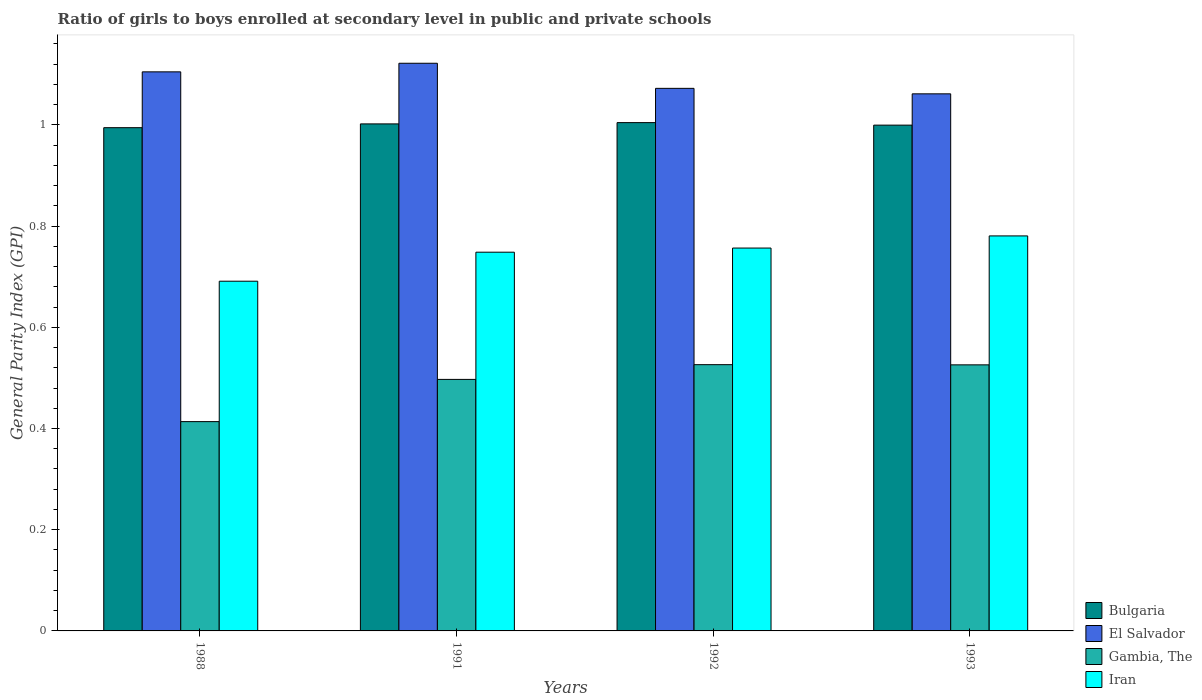Are the number of bars on each tick of the X-axis equal?
Give a very brief answer. Yes. How many bars are there on the 1st tick from the left?
Your response must be concise. 4. What is the label of the 4th group of bars from the left?
Offer a very short reply. 1993. What is the general parity index in Gambia, The in 1988?
Provide a short and direct response. 0.41. Across all years, what is the maximum general parity index in Bulgaria?
Make the answer very short. 1. Across all years, what is the minimum general parity index in El Salvador?
Give a very brief answer. 1.06. In which year was the general parity index in Bulgaria maximum?
Provide a succinct answer. 1992. What is the total general parity index in Bulgaria in the graph?
Your answer should be compact. 4. What is the difference between the general parity index in Iran in 1988 and that in 1993?
Make the answer very short. -0.09. What is the difference between the general parity index in Gambia, The in 1988 and the general parity index in Bulgaria in 1991?
Ensure brevity in your answer.  -0.59. What is the average general parity index in Iran per year?
Keep it short and to the point. 0.74. In the year 1991, what is the difference between the general parity index in El Salvador and general parity index in Gambia, The?
Make the answer very short. 0.62. What is the ratio of the general parity index in El Salvador in 1992 to that in 1993?
Ensure brevity in your answer.  1.01. Is the difference between the general parity index in El Salvador in 1988 and 1992 greater than the difference between the general parity index in Gambia, The in 1988 and 1992?
Offer a terse response. Yes. What is the difference between the highest and the second highest general parity index in Gambia, The?
Provide a succinct answer. 0. What is the difference between the highest and the lowest general parity index in Iran?
Your answer should be compact. 0.09. Is the sum of the general parity index in El Salvador in 1991 and 1992 greater than the maximum general parity index in Bulgaria across all years?
Offer a very short reply. Yes. Is it the case that in every year, the sum of the general parity index in El Salvador and general parity index in Gambia, The is greater than the sum of general parity index in Iran and general parity index in Bulgaria?
Offer a very short reply. Yes. What does the 4th bar from the left in 1993 represents?
Your answer should be compact. Iran. What does the 3rd bar from the right in 1993 represents?
Your response must be concise. El Salvador. How many bars are there?
Your answer should be compact. 16. Does the graph contain any zero values?
Provide a succinct answer. No. How many legend labels are there?
Provide a short and direct response. 4. What is the title of the graph?
Provide a short and direct response. Ratio of girls to boys enrolled at secondary level in public and private schools. What is the label or title of the Y-axis?
Your answer should be very brief. General Parity Index (GPI). What is the General Parity Index (GPI) of Bulgaria in 1988?
Give a very brief answer. 0.99. What is the General Parity Index (GPI) in El Salvador in 1988?
Keep it short and to the point. 1.1. What is the General Parity Index (GPI) of Gambia, The in 1988?
Your answer should be compact. 0.41. What is the General Parity Index (GPI) of Iran in 1988?
Offer a terse response. 0.69. What is the General Parity Index (GPI) in Bulgaria in 1991?
Offer a terse response. 1. What is the General Parity Index (GPI) of El Salvador in 1991?
Your response must be concise. 1.12. What is the General Parity Index (GPI) of Gambia, The in 1991?
Offer a terse response. 0.5. What is the General Parity Index (GPI) of Iran in 1991?
Offer a terse response. 0.75. What is the General Parity Index (GPI) of Bulgaria in 1992?
Provide a short and direct response. 1. What is the General Parity Index (GPI) in El Salvador in 1992?
Provide a succinct answer. 1.07. What is the General Parity Index (GPI) in Gambia, The in 1992?
Offer a terse response. 0.53. What is the General Parity Index (GPI) of Iran in 1992?
Your answer should be very brief. 0.76. What is the General Parity Index (GPI) of Bulgaria in 1993?
Offer a very short reply. 1. What is the General Parity Index (GPI) of El Salvador in 1993?
Provide a succinct answer. 1.06. What is the General Parity Index (GPI) in Gambia, The in 1993?
Provide a short and direct response. 0.53. What is the General Parity Index (GPI) in Iran in 1993?
Your answer should be very brief. 0.78. Across all years, what is the maximum General Parity Index (GPI) of Bulgaria?
Your response must be concise. 1. Across all years, what is the maximum General Parity Index (GPI) in El Salvador?
Your answer should be very brief. 1.12. Across all years, what is the maximum General Parity Index (GPI) in Gambia, The?
Keep it short and to the point. 0.53. Across all years, what is the maximum General Parity Index (GPI) of Iran?
Ensure brevity in your answer.  0.78. Across all years, what is the minimum General Parity Index (GPI) of Bulgaria?
Offer a terse response. 0.99. Across all years, what is the minimum General Parity Index (GPI) in El Salvador?
Provide a short and direct response. 1.06. Across all years, what is the minimum General Parity Index (GPI) of Gambia, The?
Make the answer very short. 0.41. Across all years, what is the minimum General Parity Index (GPI) of Iran?
Ensure brevity in your answer.  0.69. What is the total General Parity Index (GPI) in Bulgaria in the graph?
Give a very brief answer. 4. What is the total General Parity Index (GPI) of El Salvador in the graph?
Offer a very short reply. 4.36. What is the total General Parity Index (GPI) of Gambia, The in the graph?
Your response must be concise. 1.96. What is the total General Parity Index (GPI) of Iran in the graph?
Give a very brief answer. 2.98. What is the difference between the General Parity Index (GPI) of Bulgaria in 1988 and that in 1991?
Offer a terse response. -0.01. What is the difference between the General Parity Index (GPI) in El Salvador in 1988 and that in 1991?
Ensure brevity in your answer.  -0.02. What is the difference between the General Parity Index (GPI) of Gambia, The in 1988 and that in 1991?
Provide a succinct answer. -0.08. What is the difference between the General Parity Index (GPI) of Iran in 1988 and that in 1991?
Offer a very short reply. -0.06. What is the difference between the General Parity Index (GPI) of Bulgaria in 1988 and that in 1992?
Keep it short and to the point. -0.01. What is the difference between the General Parity Index (GPI) of El Salvador in 1988 and that in 1992?
Give a very brief answer. 0.03. What is the difference between the General Parity Index (GPI) in Gambia, The in 1988 and that in 1992?
Keep it short and to the point. -0.11. What is the difference between the General Parity Index (GPI) in Iran in 1988 and that in 1992?
Your response must be concise. -0.07. What is the difference between the General Parity Index (GPI) of Bulgaria in 1988 and that in 1993?
Make the answer very short. -0.01. What is the difference between the General Parity Index (GPI) in El Salvador in 1988 and that in 1993?
Offer a terse response. 0.04. What is the difference between the General Parity Index (GPI) of Gambia, The in 1988 and that in 1993?
Offer a terse response. -0.11. What is the difference between the General Parity Index (GPI) in Iran in 1988 and that in 1993?
Your response must be concise. -0.09. What is the difference between the General Parity Index (GPI) of Bulgaria in 1991 and that in 1992?
Your answer should be compact. -0. What is the difference between the General Parity Index (GPI) of El Salvador in 1991 and that in 1992?
Keep it short and to the point. 0.05. What is the difference between the General Parity Index (GPI) in Gambia, The in 1991 and that in 1992?
Give a very brief answer. -0.03. What is the difference between the General Parity Index (GPI) of Iran in 1991 and that in 1992?
Give a very brief answer. -0.01. What is the difference between the General Parity Index (GPI) in Bulgaria in 1991 and that in 1993?
Offer a terse response. 0. What is the difference between the General Parity Index (GPI) of El Salvador in 1991 and that in 1993?
Give a very brief answer. 0.06. What is the difference between the General Parity Index (GPI) of Gambia, The in 1991 and that in 1993?
Make the answer very short. -0.03. What is the difference between the General Parity Index (GPI) in Iran in 1991 and that in 1993?
Provide a short and direct response. -0.03. What is the difference between the General Parity Index (GPI) in Bulgaria in 1992 and that in 1993?
Give a very brief answer. 0.01. What is the difference between the General Parity Index (GPI) of El Salvador in 1992 and that in 1993?
Provide a succinct answer. 0.01. What is the difference between the General Parity Index (GPI) in Iran in 1992 and that in 1993?
Offer a very short reply. -0.02. What is the difference between the General Parity Index (GPI) of Bulgaria in 1988 and the General Parity Index (GPI) of El Salvador in 1991?
Provide a short and direct response. -0.13. What is the difference between the General Parity Index (GPI) of Bulgaria in 1988 and the General Parity Index (GPI) of Gambia, The in 1991?
Give a very brief answer. 0.5. What is the difference between the General Parity Index (GPI) of Bulgaria in 1988 and the General Parity Index (GPI) of Iran in 1991?
Provide a succinct answer. 0.25. What is the difference between the General Parity Index (GPI) of El Salvador in 1988 and the General Parity Index (GPI) of Gambia, The in 1991?
Offer a very short reply. 0.61. What is the difference between the General Parity Index (GPI) of El Salvador in 1988 and the General Parity Index (GPI) of Iran in 1991?
Give a very brief answer. 0.36. What is the difference between the General Parity Index (GPI) of Gambia, The in 1988 and the General Parity Index (GPI) of Iran in 1991?
Give a very brief answer. -0.33. What is the difference between the General Parity Index (GPI) of Bulgaria in 1988 and the General Parity Index (GPI) of El Salvador in 1992?
Your answer should be very brief. -0.08. What is the difference between the General Parity Index (GPI) in Bulgaria in 1988 and the General Parity Index (GPI) in Gambia, The in 1992?
Offer a terse response. 0.47. What is the difference between the General Parity Index (GPI) in Bulgaria in 1988 and the General Parity Index (GPI) in Iran in 1992?
Ensure brevity in your answer.  0.24. What is the difference between the General Parity Index (GPI) of El Salvador in 1988 and the General Parity Index (GPI) of Gambia, The in 1992?
Give a very brief answer. 0.58. What is the difference between the General Parity Index (GPI) of El Salvador in 1988 and the General Parity Index (GPI) of Iran in 1992?
Keep it short and to the point. 0.35. What is the difference between the General Parity Index (GPI) of Gambia, The in 1988 and the General Parity Index (GPI) of Iran in 1992?
Keep it short and to the point. -0.34. What is the difference between the General Parity Index (GPI) of Bulgaria in 1988 and the General Parity Index (GPI) of El Salvador in 1993?
Make the answer very short. -0.07. What is the difference between the General Parity Index (GPI) of Bulgaria in 1988 and the General Parity Index (GPI) of Gambia, The in 1993?
Offer a very short reply. 0.47. What is the difference between the General Parity Index (GPI) in Bulgaria in 1988 and the General Parity Index (GPI) in Iran in 1993?
Keep it short and to the point. 0.21. What is the difference between the General Parity Index (GPI) of El Salvador in 1988 and the General Parity Index (GPI) of Gambia, The in 1993?
Your answer should be very brief. 0.58. What is the difference between the General Parity Index (GPI) of El Salvador in 1988 and the General Parity Index (GPI) of Iran in 1993?
Provide a short and direct response. 0.32. What is the difference between the General Parity Index (GPI) of Gambia, The in 1988 and the General Parity Index (GPI) of Iran in 1993?
Make the answer very short. -0.37. What is the difference between the General Parity Index (GPI) in Bulgaria in 1991 and the General Parity Index (GPI) in El Salvador in 1992?
Your response must be concise. -0.07. What is the difference between the General Parity Index (GPI) of Bulgaria in 1991 and the General Parity Index (GPI) of Gambia, The in 1992?
Ensure brevity in your answer.  0.48. What is the difference between the General Parity Index (GPI) of Bulgaria in 1991 and the General Parity Index (GPI) of Iran in 1992?
Ensure brevity in your answer.  0.25. What is the difference between the General Parity Index (GPI) in El Salvador in 1991 and the General Parity Index (GPI) in Gambia, The in 1992?
Give a very brief answer. 0.6. What is the difference between the General Parity Index (GPI) in El Salvador in 1991 and the General Parity Index (GPI) in Iran in 1992?
Provide a short and direct response. 0.37. What is the difference between the General Parity Index (GPI) of Gambia, The in 1991 and the General Parity Index (GPI) of Iran in 1992?
Keep it short and to the point. -0.26. What is the difference between the General Parity Index (GPI) in Bulgaria in 1991 and the General Parity Index (GPI) in El Salvador in 1993?
Ensure brevity in your answer.  -0.06. What is the difference between the General Parity Index (GPI) in Bulgaria in 1991 and the General Parity Index (GPI) in Gambia, The in 1993?
Make the answer very short. 0.48. What is the difference between the General Parity Index (GPI) in Bulgaria in 1991 and the General Parity Index (GPI) in Iran in 1993?
Make the answer very short. 0.22. What is the difference between the General Parity Index (GPI) in El Salvador in 1991 and the General Parity Index (GPI) in Gambia, The in 1993?
Offer a terse response. 0.6. What is the difference between the General Parity Index (GPI) in El Salvador in 1991 and the General Parity Index (GPI) in Iran in 1993?
Keep it short and to the point. 0.34. What is the difference between the General Parity Index (GPI) in Gambia, The in 1991 and the General Parity Index (GPI) in Iran in 1993?
Your answer should be very brief. -0.28. What is the difference between the General Parity Index (GPI) of Bulgaria in 1992 and the General Parity Index (GPI) of El Salvador in 1993?
Give a very brief answer. -0.06. What is the difference between the General Parity Index (GPI) in Bulgaria in 1992 and the General Parity Index (GPI) in Gambia, The in 1993?
Your answer should be very brief. 0.48. What is the difference between the General Parity Index (GPI) of Bulgaria in 1992 and the General Parity Index (GPI) of Iran in 1993?
Provide a short and direct response. 0.22. What is the difference between the General Parity Index (GPI) in El Salvador in 1992 and the General Parity Index (GPI) in Gambia, The in 1993?
Provide a succinct answer. 0.55. What is the difference between the General Parity Index (GPI) of El Salvador in 1992 and the General Parity Index (GPI) of Iran in 1993?
Ensure brevity in your answer.  0.29. What is the difference between the General Parity Index (GPI) in Gambia, The in 1992 and the General Parity Index (GPI) in Iran in 1993?
Offer a terse response. -0.25. What is the average General Parity Index (GPI) in El Salvador per year?
Your answer should be very brief. 1.09. What is the average General Parity Index (GPI) of Gambia, The per year?
Make the answer very short. 0.49. What is the average General Parity Index (GPI) in Iran per year?
Provide a short and direct response. 0.74. In the year 1988, what is the difference between the General Parity Index (GPI) of Bulgaria and General Parity Index (GPI) of El Salvador?
Provide a short and direct response. -0.11. In the year 1988, what is the difference between the General Parity Index (GPI) of Bulgaria and General Parity Index (GPI) of Gambia, The?
Your answer should be compact. 0.58. In the year 1988, what is the difference between the General Parity Index (GPI) of Bulgaria and General Parity Index (GPI) of Iran?
Provide a succinct answer. 0.3. In the year 1988, what is the difference between the General Parity Index (GPI) in El Salvador and General Parity Index (GPI) in Gambia, The?
Give a very brief answer. 0.69. In the year 1988, what is the difference between the General Parity Index (GPI) in El Salvador and General Parity Index (GPI) in Iran?
Keep it short and to the point. 0.41. In the year 1988, what is the difference between the General Parity Index (GPI) of Gambia, The and General Parity Index (GPI) of Iran?
Your response must be concise. -0.28. In the year 1991, what is the difference between the General Parity Index (GPI) of Bulgaria and General Parity Index (GPI) of El Salvador?
Make the answer very short. -0.12. In the year 1991, what is the difference between the General Parity Index (GPI) of Bulgaria and General Parity Index (GPI) of Gambia, The?
Offer a terse response. 0.5. In the year 1991, what is the difference between the General Parity Index (GPI) in Bulgaria and General Parity Index (GPI) in Iran?
Offer a very short reply. 0.25. In the year 1991, what is the difference between the General Parity Index (GPI) of El Salvador and General Parity Index (GPI) of Gambia, The?
Provide a succinct answer. 0.62. In the year 1991, what is the difference between the General Parity Index (GPI) in El Salvador and General Parity Index (GPI) in Iran?
Keep it short and to the point. 0.37. In the year 1991, what is the difference between the General Parity Index (GPI) of Gambia, The and General Parity Index (GPI) of Iran?
Make the answer very short. -0.25. In the year 1992, what is the difference between the General Parity Index (GPI) of Bulgaria and General Parity Index (GPI) of El Salvador?
Ensure brevity in your answer.  -0.07. In the year 1992, what is the difference between the General Parity Index (GPI) in Bulgaria and General Parity Index (GPI) in Gambia, The?
Ensure brevity in your answer.  0.48. In the year 1992, what is the difference between the General Parity Index (GPI) in Bulgaria and General Parity Index (GPI) in Iran?
Provide a short and direct response. 0.25. In the year 1992, what is the difference between the General Parity Index (GPI) in El Salvador and General Parity Index (GPI) in Gambia, The?
Keep it short and to the point. 0.55. In the year 1992, what is the difference between the General Parity Index (GPI) of El Salvador and General Parity Index (GPI) of Iran?
Make the answer very short. 0.32. In the year 1992, what is the difference between the General Parity Index (GPI) of Gambia, The and General Parity Index (GPI) of Iran?
Provide a succinct answer. -0.23. In the year 1993, what is the difference between the General Parity Index (GPI) in Bulgaria and General Parity Index (GPI) in El Salvador?
Your response must be concise. -0.06. In the year 1993, what is the difference between the General Parity Index (GPI) in Bulgaria and General Parity Index (GPI) in Gambia, The?
Offer a terse response. 0.47. In the year 1993, what is the difference between the General Parity Index (GPI) of Bulgaria and General Parity Index (GPI) of Iran?
Your answer should be very brief. 0.22. In the year 1993, what is the difference between the General Parity Index (GPI) of El Salvador and General Parity Index (GPI) of Gambia, The?
Offer a terse response. 0.54. In the year 1993, what is the difference between the General Parity Index (GPI) of El Salvador and General Parity Index (GPI) of Iran?
Your response must be concise. 0.28. In the year 1993, what is the difference between the General Parity Index (GPI) of Gambia, The and General Parity Index (GPI) of Iran?
Your answer should be compact. -0.25. What is the ratio of the General Parity Index (GPI) of El Salvador in 1988 to that in 1991?
Give a very brief answer. 0.98. What is the ratio of the General Parity Index (GPI) of Gambia, The in 1988 to that in 1991?
Offer a terse response. 0.83. What is the ratio of the General Parity Index (GPI) of Iran in 1988 to that in 1991?
Your answer should be very brief. 0.92. What is the ratio of the General Parity Index (GPI) in El Salvador in 1988 to that in 1992?
Your response must be concise. 1.03. What is the ratio of the General Parity Index (GPI) in Gambia, The in 1988 to that in 1992?
Offer a terse response. 0.79. What is the ratio of the General Parity Index (GPI) of Iran in 1988 to that in 1992?
Keep it short and to the point. 0.91. What is the ratio of the General Parity Index (GPI) in El Salvador in 1988 to that in 1993?
Give a very brief answer. 1.04. What is the ratio of the General Parity Index (GPI) of Gambia, The in 1988 to that in 1993?
Provide a succinct answer. 0.79. What is the ratio of the General Parity Index (GPI) of Iran in 1988 to that in 1993?
Offer a terse response. 0.89. What is the ratio of the General Parity Index (GPI) in Bulgaria in 1991 to that in 1992?
Make the answer very short. 1. What is the ratio of the General Parity Index (GPI) of El Salvador in 1991 to that in 1992?
Your answer should be compact. 1.05. What is the ratio of the General Parity Index (GPI) of Gambia, The in 1991 to that in 1992?
Keep it short and to the point. 0.94. What is the ratio of the General Parity Index (GPI) of Iran in 1991 to that in 1992?
Keep it short and to the point. 0.99. What is the ratio of the General Parity Index (GPI) of Bulgaria in 1991 to that in 1993?
Your answer should be compact. 1. What is the ratio of the General Parity Index (GPI) of El Salvador in 1991 to that in 1993?
Make the answer very short. 1.06. What is the ratio of the General Parity Index (GPI) of Gambia, The in 1991 to that in 1993?
Make the answer very short. 0.95. What is the ratio of the General Parity Index (GPI) of Iran in 1991 to that in 1993?
Make the answer very short. 0.96. What is the ratio of the General Parity Index (GPI) in El Salvador in 1992 to that in 1993?
Provide a succinct answer. 1.01. What is the ratio of the General Parity Index (GPI) in Iran in 1992 to that in 1993?
Your answer should be compact. 0.97. What is the difference between the highest and the second highest General Parity Index (GPI) of Bulgaria?
Make the answer very short. 0. What is the difference between the highest and the second highest General Parity Index (GPI) in El Salvador?
Give a very brief answer. 0.02. What is the difference between the highest and the second highest General Parity Index (GPI) of Iran?
Offer a very short reply. 0.02. What is the difference between the highest and the lowest General Parity Index (GPI) in Bulgaria?
Give a very brief answer. 0.01. What is the difference between the highest and the lowest General Parity Index (GPI) of El Salvador?
Keep it short and to the point. 0.06. What is the difference between the highest and the lowest General Parity Index (GPI) in Gambia, The?
Offer a terse response. 0.11. What is the difference between the highest and the lowest General Parity Index (GPI) of Iran?
Make the answer very short. 0.09. 